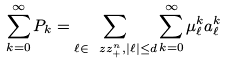<formula> <loc_0><loc_0><loc_500><loc_500>\sum _ { k = 0 } ^ { \infty } P _ { k } = \sum _ { \ell \in \ z z _ { + } ^ { n } , | \ell | \leq d } \sum _ { k = 0 } ^ { \infty } \mu _ { \ell } ^ { k } a _ { \ell } ^ { k }</formula> 